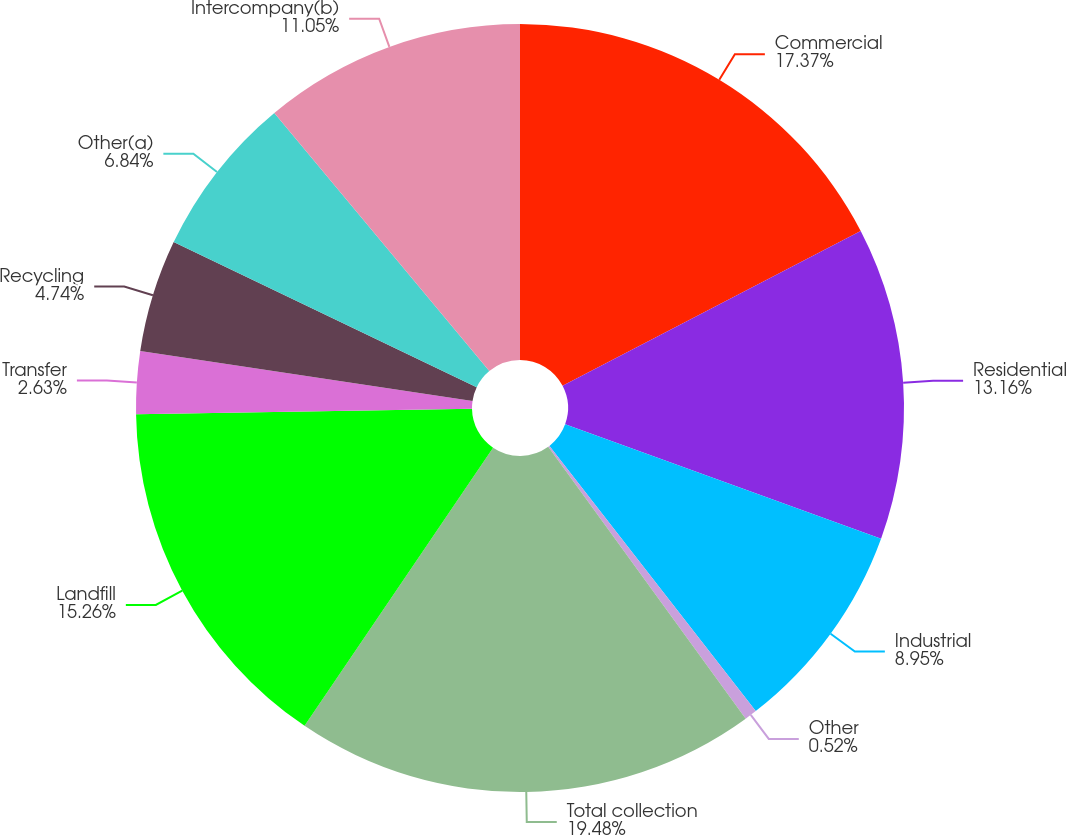Convert chart. <chart><loc_0><loc_0><loc_500><loc_500><pie_chart><fcel>Commercial<fcel>Residential<fcel>Industrial<fcel>Other<fcel>Total collection<fcel>Landfill<fcel>Transfer<fcel>Recycling<fcel>Other(a)<fcel>Intercompany(b)<nl><fcel>17.37%<fcel>13.16%<fcel>8.95%<fcel>0.52%<fcel>19.48%<fcel>15.26%<fcel>2.63%<fcel>4.74%<fcel>6.84%<fcel>11.05%<nl></chart> 